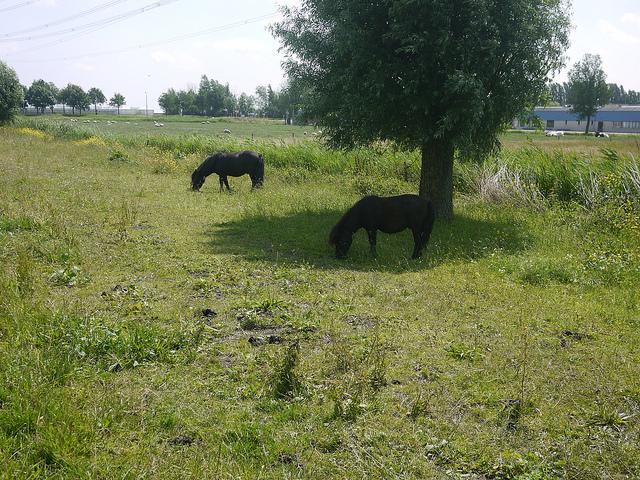What kind of horses are these?
Keep it brief. Ponies. Are these horses Tall?
Short answer required. No. How many animals under the tree?
Concise answer only. 2. 